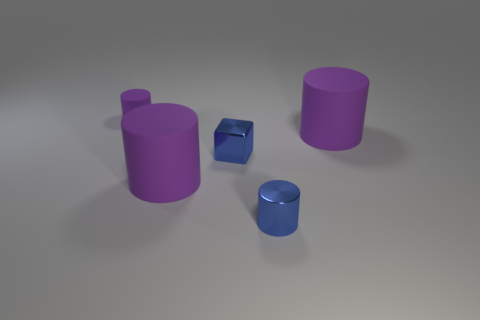Subtract all metal cylinders. How many cylinders are left? 3 Subtract all blue cylinders. How many cylinders are left? 3 Subtract all yellow blocks. How many purple cylinders are left? 3 Subtract all brown cylinders. Subtract all blue cubes. How many cylinders are left? 4 Add 3 small metal things. How many objects exist? 8 Subtract all cylinders. How many objects are left? 1 Add 1 tiny blue objects. How many tiny blue objects exist? 3 Subtract 0 red cylinders. How many objects are left? 5 Subtract all large rubber objects. Subtract all shiny things. How many objects are left? 1 Add 4 metallic things. How many metallic things are left? 6 